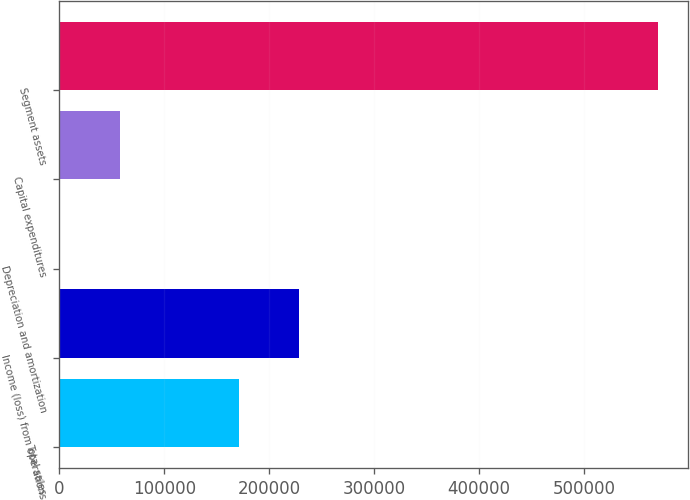Convert chart. <chart><loc_0><loc_0><loc_500><loc_500><bar_chart><fcel>Total sales<fcel>Income (loss) from operations<fcel>Depreciation and amortization<fcel>Capital expenditures<fcel>Segment assets<nl><fcel>171365<fcel>228337<fcel>451<fcel>57422.4<fcel>570165<nl></chart> 